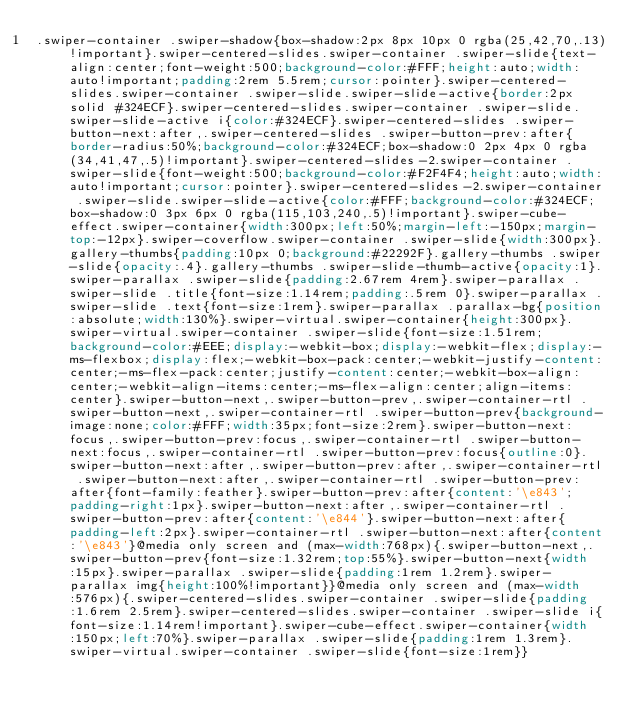Convert code to text. <code><loc_0><loc_0><loc_500><loc_500><_CSS_>.swiper-container .swiper-shadow{box-shadow:2px 8px 10px 0 rgba(25,42,70,.13)!important}.swiper-centered-slides.swiper-container .swiper-slide{text-align:center;font-weight:500;background-color:#FFF;height:auto;width:auto!important;padding:2rem 5.5rem;cursor:pointer}.swiper-centered-slides.swiper-container .swiper-slide.swiper-slide-active{border:2px solid #324ECF}.swiper-centered-slides.swiper-container .swiper-slide.swiper-slide-active i{color:#324ECF}.swiper-centered-slides .swiper-button-next:after,.swiper-centered-slides .swiper-button-prev:after{border-radius:50%;background-color:#324ECF;box-shadow:0 2px 4px 0 rgba(34,41,47,.5)!important}.swiper-centered-slides-2.swiper-container .swiper-slide{font-weight:500;background-color:#F2F4F4;height:auto;width:auto!important;cursor:pointer}.swiper-centered-slides-2.swiper-container .swiper-slide.swiper-slide-active{color:#FFF;background-color:#324ECF;box-shadow:0 3px 6px 0 rgba(115,103,240,.5)!important}.swiper-cube-effect.swiper-container{width:300px;left:50%;margin-left:-150px;margin-top:-12px}.swiper-coverflow.swiper-container .swiper-slide{width:300px}.gallery-thumbs{padding:10px 0;background:#22292F}.gallery-thumbs .swiper-slide{opacity:.4}.gallery-thumbs .swiper-slide-thumb-active{opacity:1}.swiper-parallax .swiper-slide{padding:2.67rem 4rem}.swiper-parallax .swiper-slide .title{font-size:1.14rem;padding:.5rem 0}.swiper-parallax .swiper-slide .text{font-size:1rem}.swiper-parallax .parallax-bg{position:absolute;width:130%}.swiper-virtual.swiper-container{height:300px}.swiper-virtual.swiper-container .swiper-slide{font-size:1.51rem;background-color:#EEE;display:-webkit-box;display:-webkit-flex;display:-ms-flexbox;display:flex;-webkit-box-pack:center;-webkit-justify-content:center;-ms-flex-pack:center;justify-content:center;-webkit-box-align:center;-webkit-align-items:center;-ms-flex-align:center;align-items:center}.swiper-button-next,.swiper-button-prev,.swiper-container-rtl .swiper-button-next,.swiper-container-rtl .swiper-button-prev{background-image:none;color:#FFF;width:35px;font-size:2rem}.swiper-button-next:focus,.swiper-button-prev:focus,.swiper-container-rtl .swiper-button-next:focus,.swiper-container-rtl .swiper-button-prev:focus{outline:0}.swiper-button-next:after,.swiper-button-prev:after,.swiper-container-rtl .swiper-button-next:after,.swiper-container-rtl .swiper-button-prev:after{font-family:feather}.swiper-button-prev:after{content:'\e843';padding-right:1px}.swiper-button-next:after,.swiper-container-rtl .swiper-button-prev:after{content:'\e844'}.swiper-button-next:after{padding-left:2px}.swiper-container-rtl .swiper-button-next:after{content:'\e843'}@media only screen and (max-width:768px){.swiper-button-next,.swiper-button-prev{font-size:1.32rem;top:55%}.swiper-button-next{width:15px}.swiper-parallax .swiper-slide{padding:1rem 1.2rem}.swiper-parallax img{height:100%!important}}@media only screen and (max-width:576px){.swiper-centered-slides.swiper-container .swiper-slide{padding:1.6rem 2.5rem}.swiper-centered-slides.swiper-container .swiper-slide i{font-size:1.14rem!important}.swiper-cube-effect.swiper-container{width:150px;left:70%}.swiper-parallax .swiper-slide{padding:1rem 1.3rem}.swiper-virtual.swiper-container .swiper-slide{font-size:1rem}}</code> 